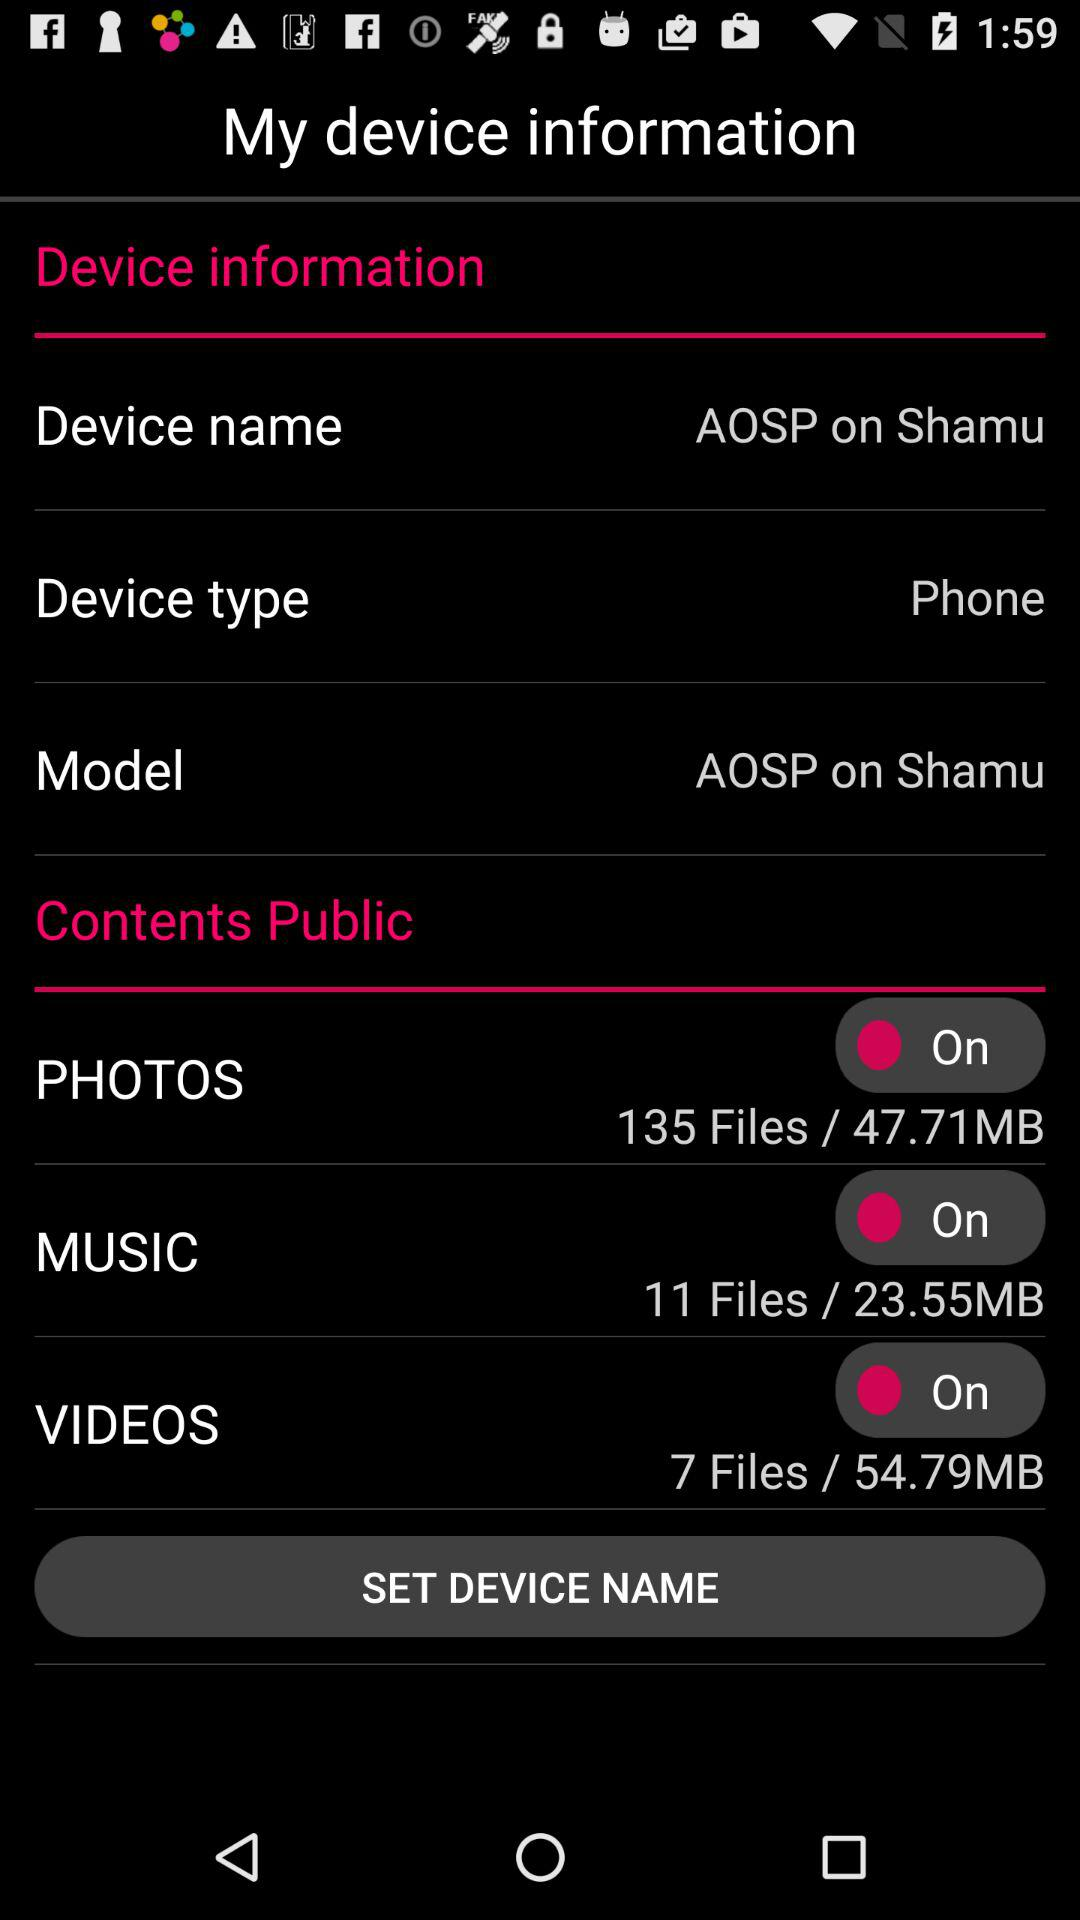What is the status of the "PHOTOS"? The status is "On". 